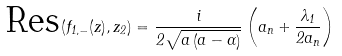Convert formula to latex. <formula><loc_0><loc_0><loc_500><loc_500>\text {Res} \left ( f _ { 1 , - } ( z ) , z _ { 2 } \right ) = \frac { i } { 2 \sqrt { a \left ( a - \alpha \right ) } } \left ( a _ { n } + \frac { \lambda _ { 1 } } { 2 a _ { n } } \right )</formula> 